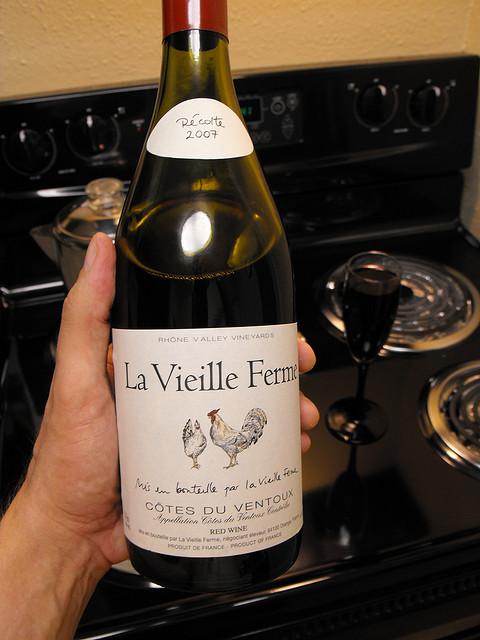What does the bottle contain?
Write a very short answer. Wine. What brand of drink is this?
Quick response, please. La vieille ferme. What region is this wine from?
Keep it brief. France. 